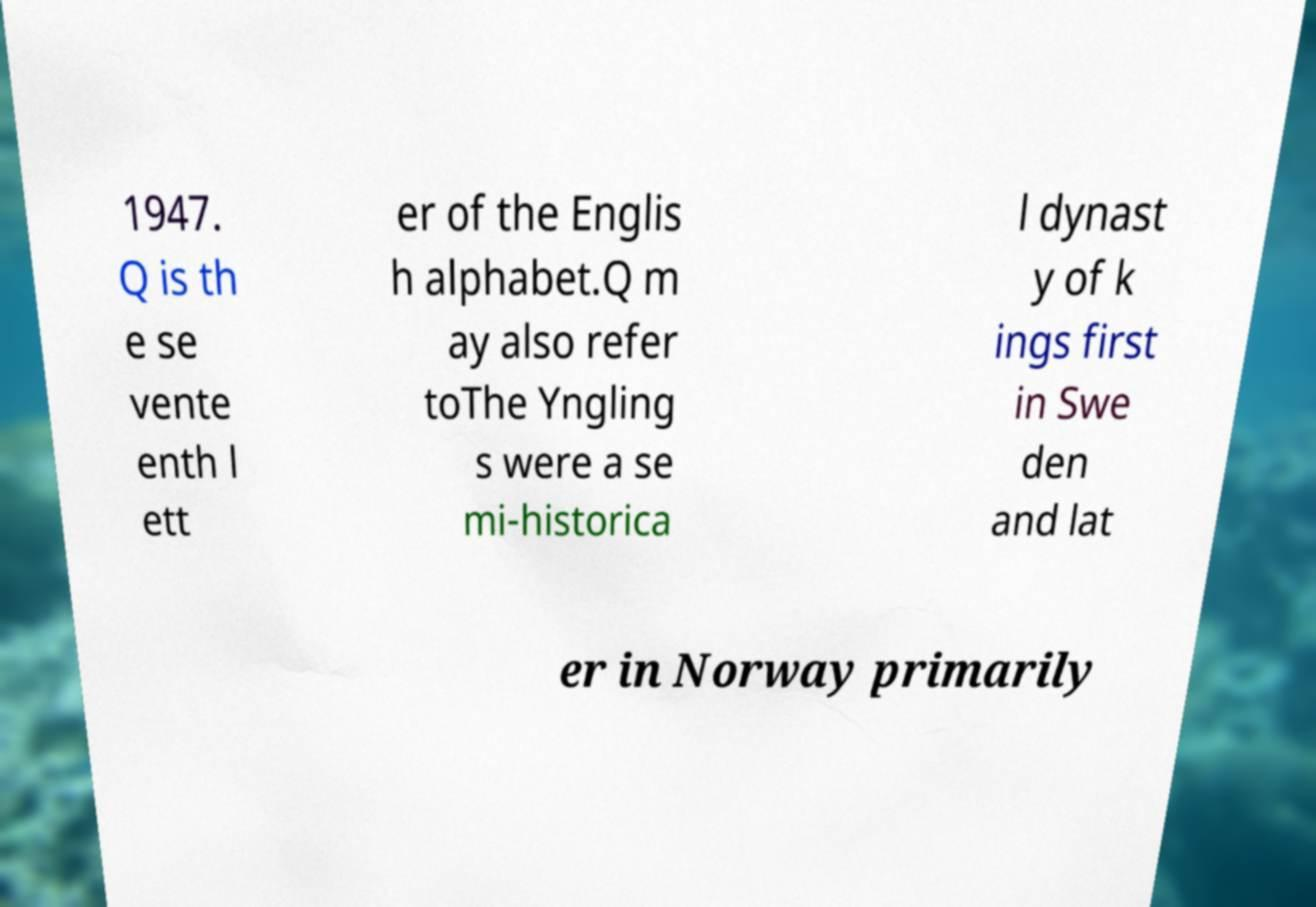Could you extract and type out the text from this image? 1947. Q is th e se vente enth l ett er of the Englis h alphabet.Q m ay also refer toThe Yngling s were a se mi-historica l dynast y of k ings first in Swe den and lat er in Norway primarily 